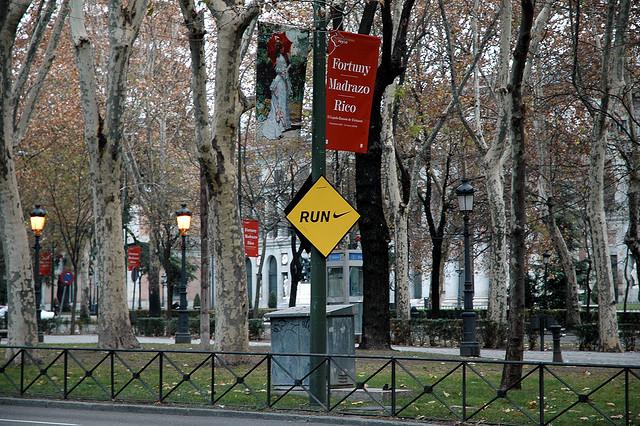Is someone having a picnic in the park?
Concise answer only. No. What season is this?
Give a very brief answer. Fall. What color is the photo?
Write a very short answer. Color. How many street lamps are lit?
Quick response, please. 2. What does the yellow sign say?
Short answer required. Run. What symbol is next to the word on the yellow sign?
Write a very short answer. Nike. What vehicle is on the sign?
Quick response, please. None. 